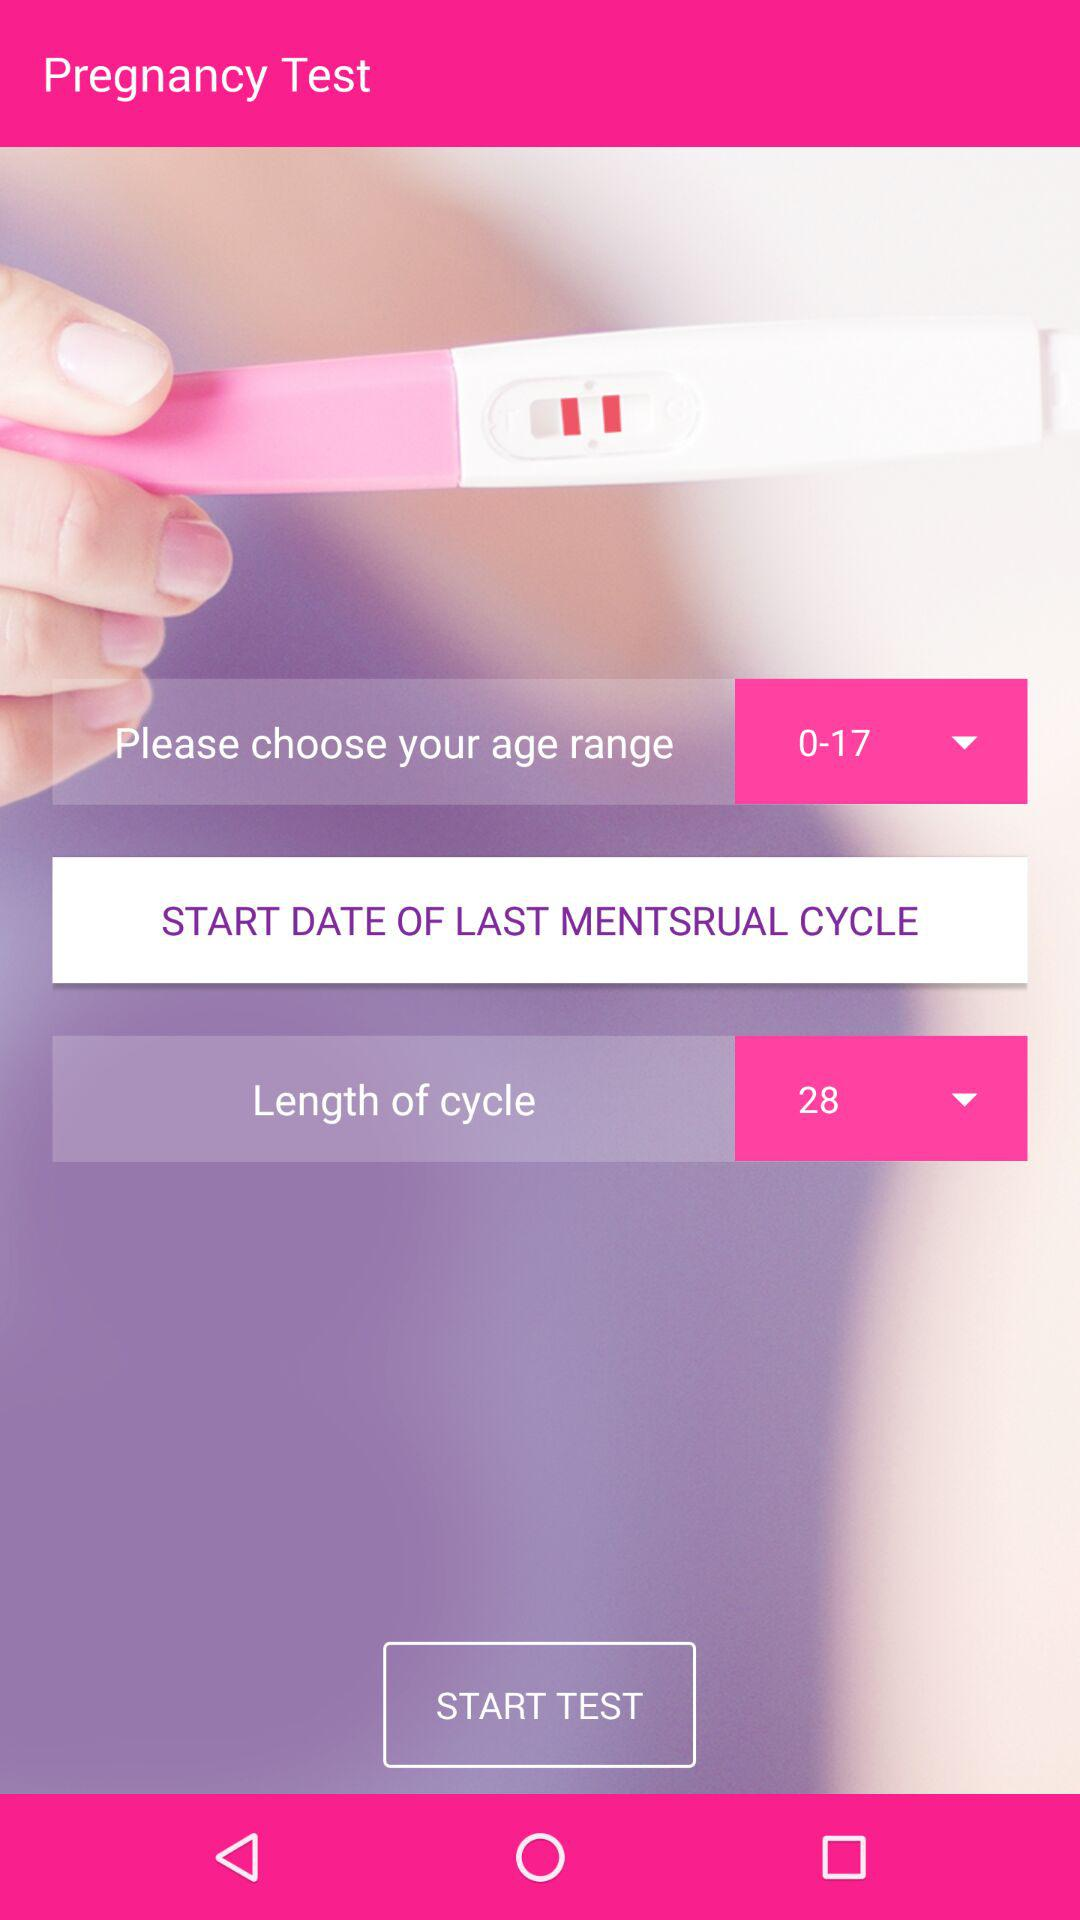What is the length of the cycle? The length of the cycle is 28. 